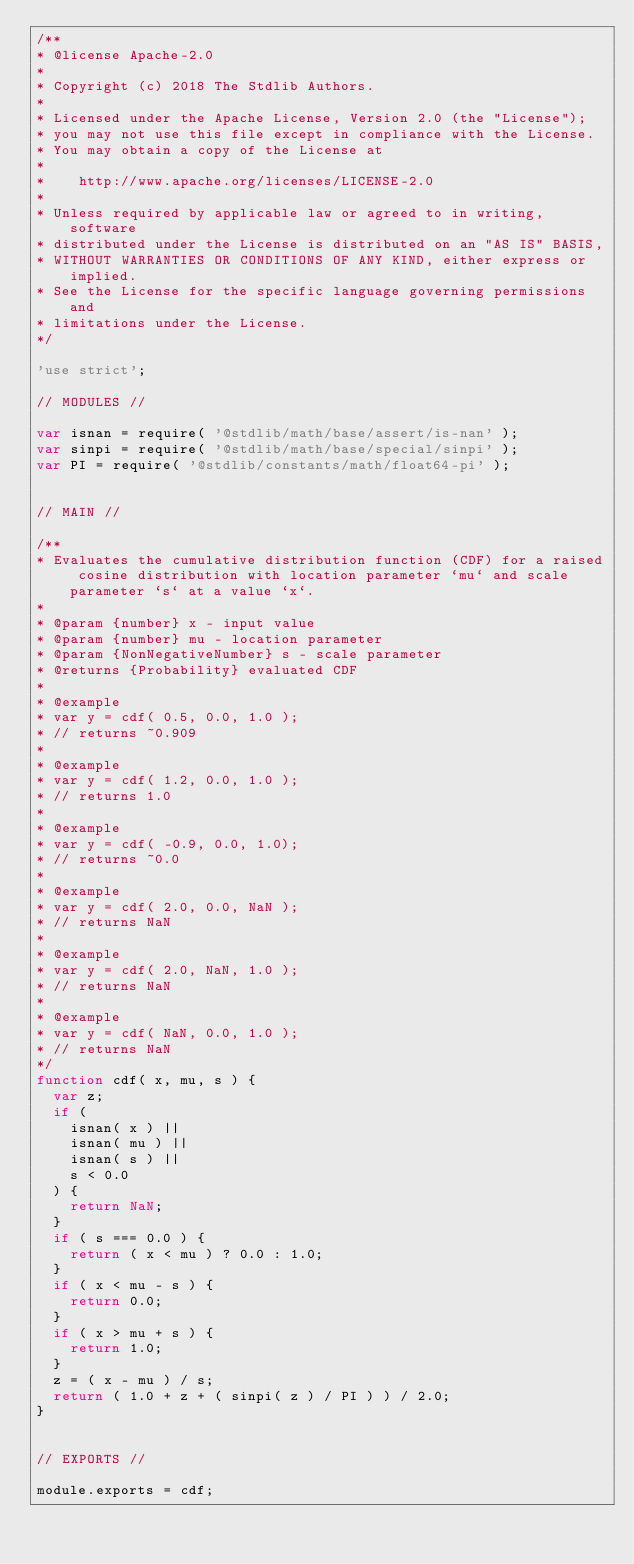<code> <loc_0><loc_0><loc_500><loc_500><_JavaScript_>/**
* @license Apache-2.0
*
* Copyright (c) 2018 The Stdlib Authors.
*
* Licensed under the Apache License, Version 2.0 (the "License");
* you may not use this file except in compliance with the License.
* You may obtain a copy of the License at
*
*    http://www.apache.org/licenses/LICENSE-2.0
*
* Unless required by applicable law or agreed to in writing, software
* distributed under the License is distributed on an "AS IS" BASIS,
* WITHOUT WARRANTIES OR CONDITIONS OF ANY KIND, either express or implied.
* See the License for the specific language governing permissions and
* limitations under the License.
*/

'use strict';

// MODULES //

var isnan = require( '@stdlib/math/base/assert/is-nan' );
var sinpi = require( '@stdlib/math/base/special/sinpi' );
var PI = require( '@stdlib/constants/math/float64-pi' );


// MAIN //

/**
* Evaluates the cumulative distribution function (CDF) for a raised cosine distribution with location parameter `mu` and scale parameter `s` at a value `x`.
*
* @param {number} x - input value
* @param {number} mu - location parameter
* @param {NonNegativeNumber} s - scale parameter
* @returns {Probability} evaluated CDF
*
* @example
* var y = cdf( 0.5, 0.0, 1.0 );
* // returns ~0.909
*
* @example
* var y = cdf( 1.2, 0.0, 1.0 );
* // returns 1.0
*
* @example
* var y = cdf( -0.9, 0.0, 1.0);
* // returns ~0.0
*
* @example
* var y = cdf( 2.0, 0.0, NaN );
* // returns NaN
*
* @example
* var y = cdf( 2.0, NaN, 1.0 );
* // returns NaN
*
* @example
* var y = cdf( NaN, 0.0, 1.0 );
* // returns NaN
*/
function cdf( x, mu, s ) {
	var z;
	if (
		isnan( x ) ||
		isnan( mu ) ||
		isnan( s ) ||
		s < 0.0
	) {
		return NaN;
	}
	if ( s === 0.0 ) {
		return ( x < mu ) ? 0.0 : 1.0;
	}
	if ( x < mu - s ) {
		return 0.0;
	}
	if ( x > mu + s ) {
		return 1.0;
	}
	z = ( x - mu ) / s;
	return ( 1.0 + z + ( sinpi( z ) / PI ) ) / 2.0;
}


// EXPORTS //

module.exports = cdf;
</code> 